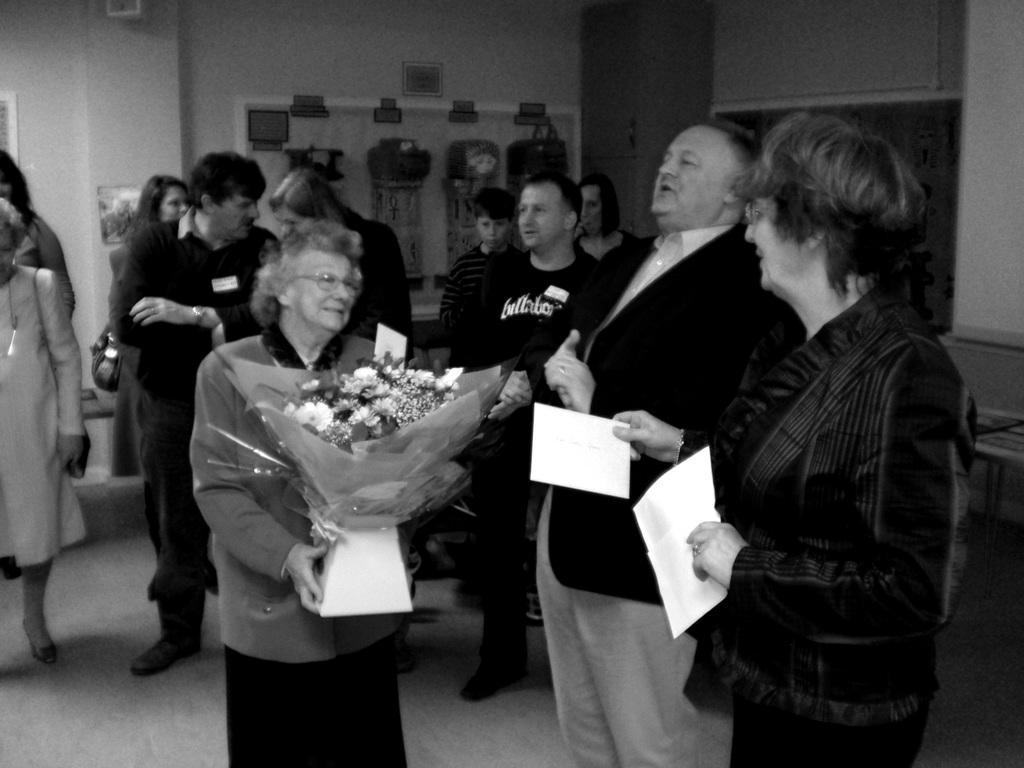Could you give a brief overview of what you see in this image? This is a black and white image. In this image we can see people standing on the floor and one of them is holding a bouquet in the hands. In the background we can see walls, board and table. 